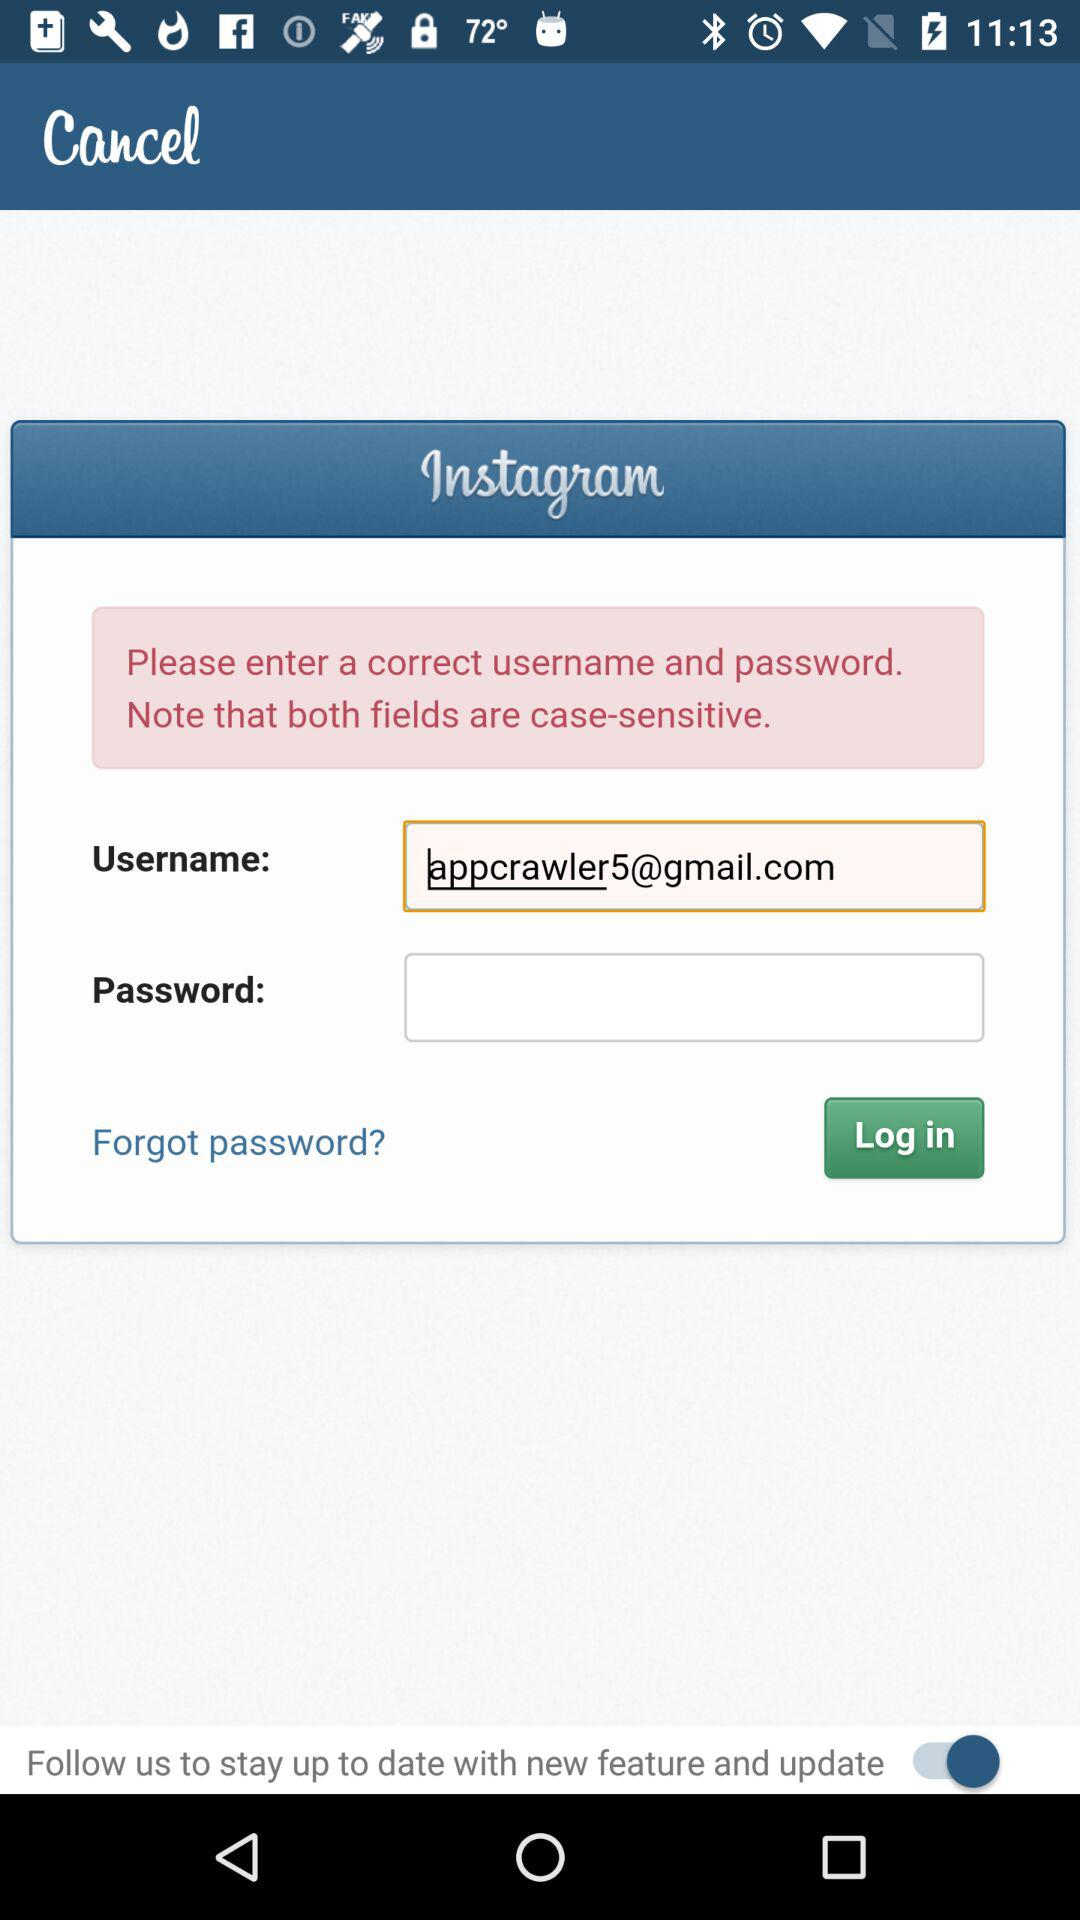What's the Google mail address used by a user in place of their username? The Google mail address is appcrawler5@gmail.com. 